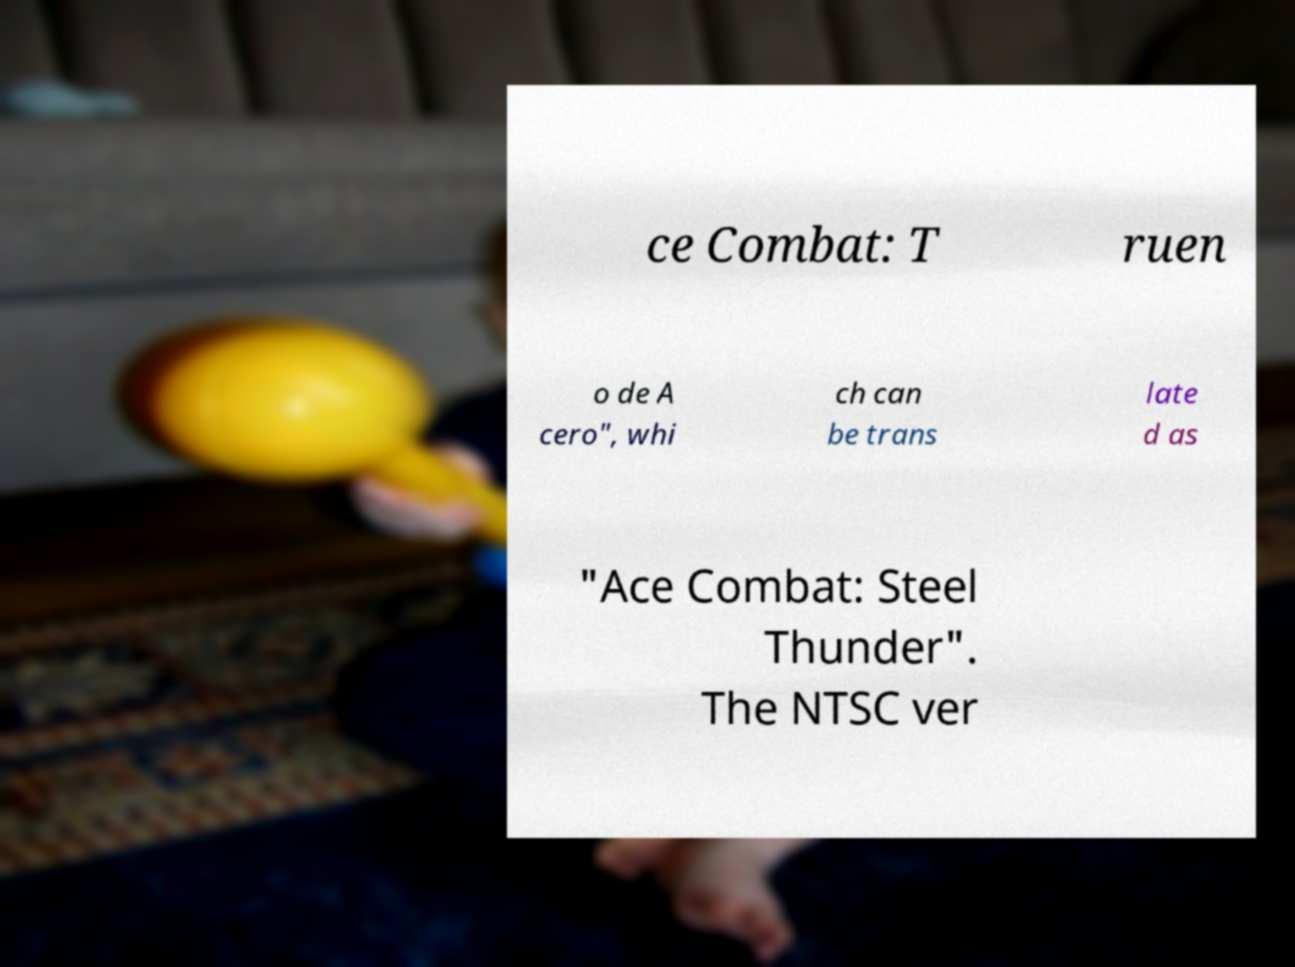Can you accurately transcribe the text from the provided image for me? ce Combat: T ruen o de A cero", whi ch can be trans late d as "Ace Combat: Steel Thunder". The NTSC ver 